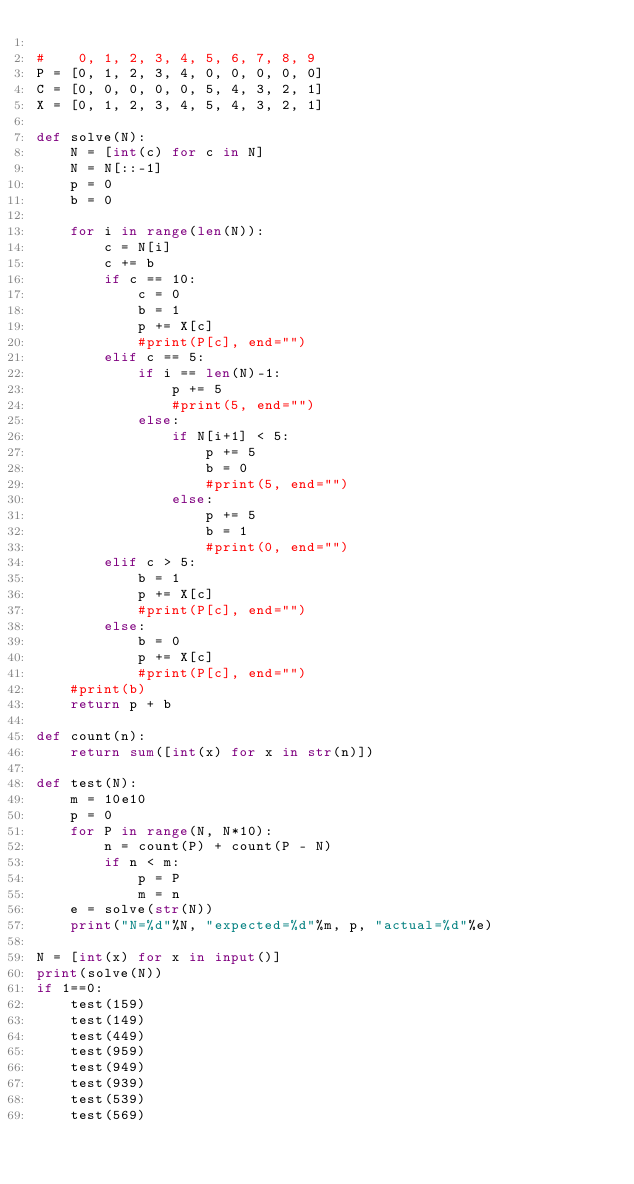<code> <loc_0><loc_0><loc_500><loc_500><_Python_>
#    0, 1, 2, 3, 4, 5, 6, 7, 8, 9
P = [0, 1, 2, 3, 4, 0, 0, 0, 0, 0]
C = [0, 0, 0, 0, 0, 5, 4, 3, 2, 1]
X = [0, 1, 2, 3, 4, 5, 4, 3, 2, 1]

def solve(N):
    N = [int(c) for c in N]
    N = N[::-1]
    p = 0
    b = 0

    for i in range(len(N)):
        c = N[i]
        c += b
        if c == 10:
            c = 0
            b = 1
            p += X[c]
            #print(P[c], end="")
        elif c == 5:
            if i == len(N)-1:
                p += 5
                #print(5, end="")
            else:
                if N[i+1] < 5:
                    p += 5
                    b = 0
                    #print(5, end="")
                else:
                    p += 5    
                    b = 1
                    #print(0, end="")
        elif c > 5:
            b = 1
            p += X[c]
            #print(P[c], end="")
        else:
            b = 0
            p += X[c]
            #print(P[c], end="")
    #print(b)
    return p + b

def count(n):
    return sum([int(x) for x in str(n)])

def test(N):
    m = 10e10
    p = 0
    for P in range(N, N*10):
        n = count(P) + count(P - N)
        if n < m:
            p = P
            m = n
    e = solve(str(N))
    print("N=%d"%N, "expected=%d"%m, p, "actual=%d"%e)

N = [int(x) for x in input()]
print(solve(N))
if 1==0:
    test(159)
    test(149)
    test(449)
    test(959)
    test(949)
    test(939)
    test(539)
    test(569)

</code> 